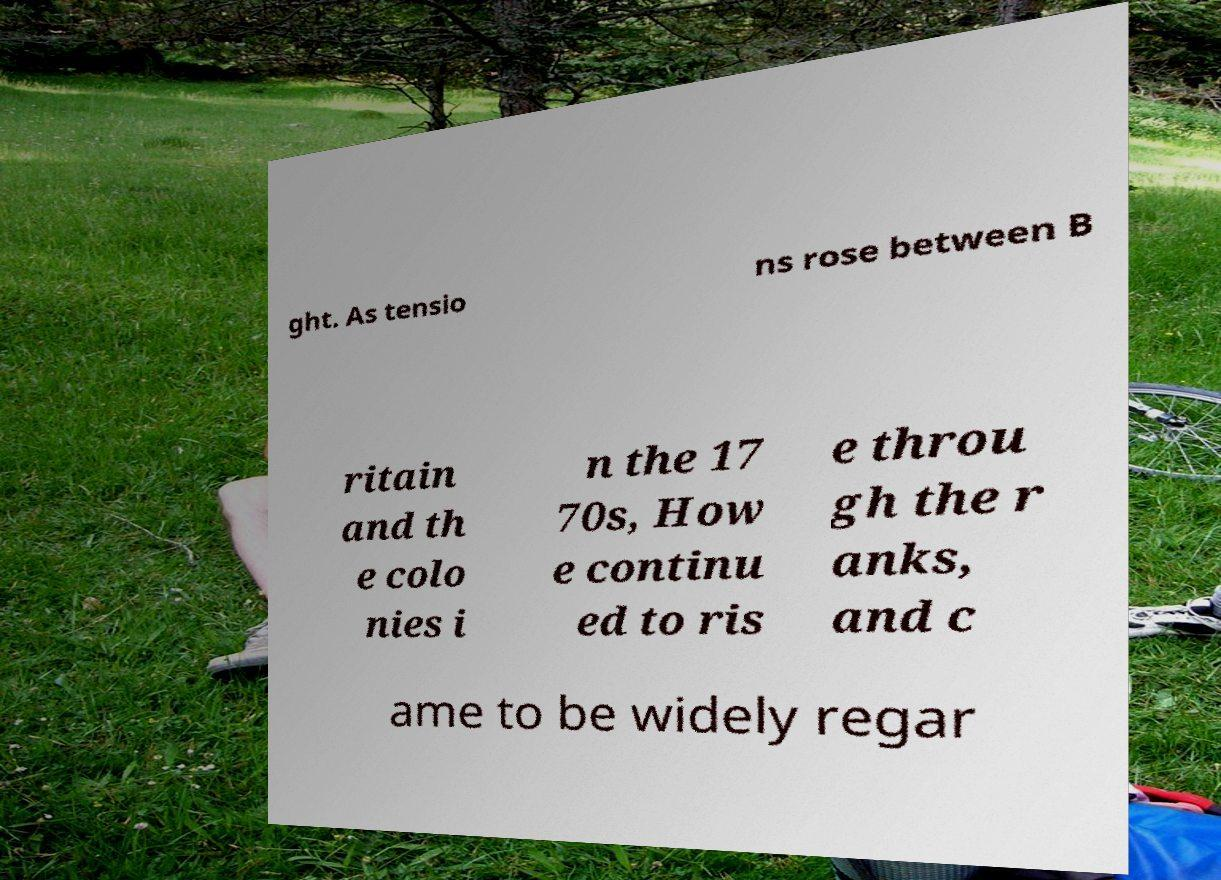Could you assist in decoding the text presented in this image and type it out clearly? ght. As tensio ns rose between B ritain and th e colo nies i n the 17 70s, How e continu ed to ris e throu gh the r anks, and c ame to be widely regar 